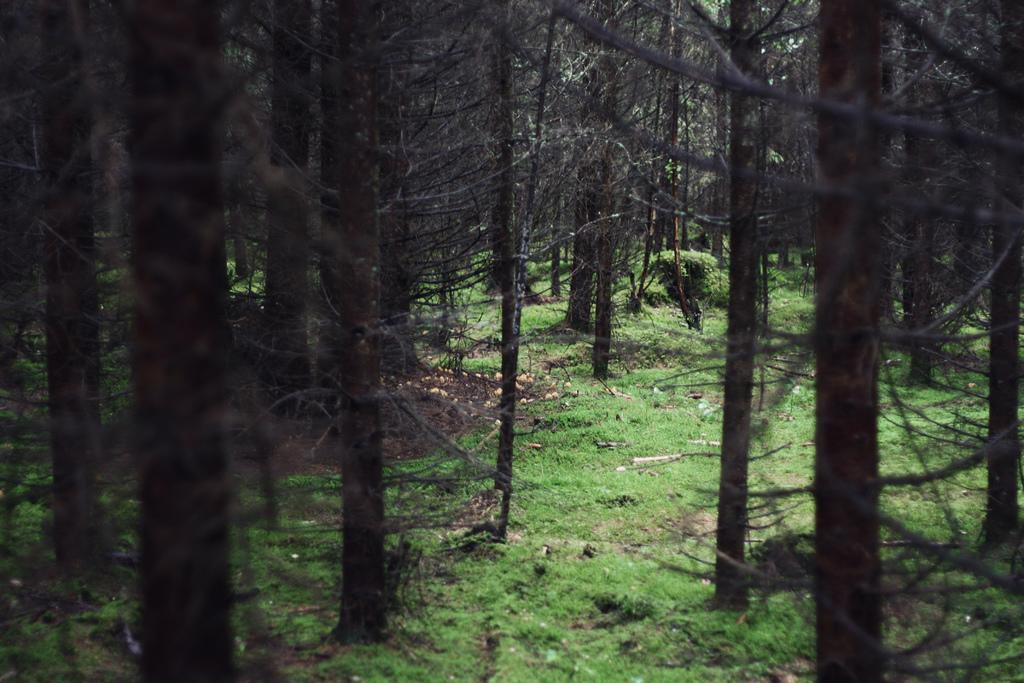What type of living organisms can be seen in the image? Plants can be seen in the image. What is the color of the plants in the image? The plants are green in color. What type of trees can be seen in the image? There are dried trees in the image. How does the wrench help the plants grow in the image? There is no wrench present in the image, so it cannot help the plants grow. 